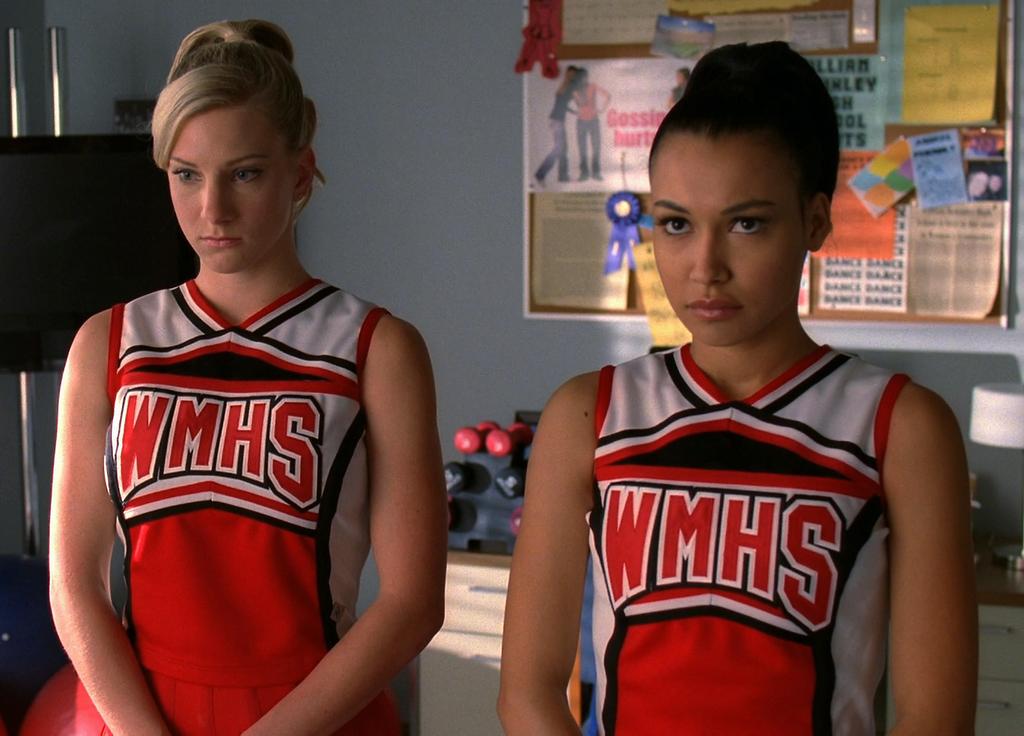What is the abbreviated school name on the uniform?
Keep it short and to the point. Wmhs. What is the team name on the shirts?
Provide a short and direct response. Wmhs. 